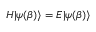Convert formula to latex. <formula><loc_0><loc_0><loc_500><loc_500>H | \psi ( \beta ) \rangle = E | \psi ( \beta ) \rangle</formula> 